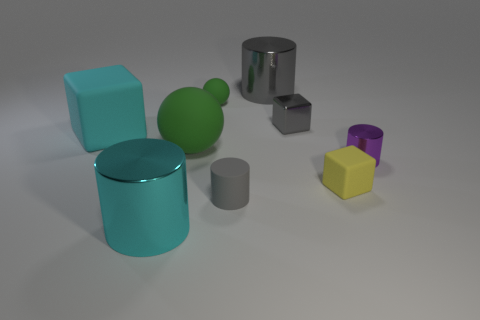There is a object left of the shiny thing that is in front of the tiny purple metallic cylinder; what is its material?
Provide a short and direct response. Rubber. Is the number of tiny things that are behind the cyan matte block greater than the number of tiny yellow things?
Offer a terse response. Yes. Are any tiny blue things visible?
Provide a succinct answer. No. There is a big cylinder that is in front of the large rubber cube; what color is it?
Make the answer very short. Cyan. There is a ball that is the same size as the yellow rubber object; what is its material?
Offer a very short reply. Rubber. What number of other objects are there of the same material as the gray block?
Provide a short and direct response. 3. There is a large thing that is both left of the big green matte ball and behind the rubber cylinder; what is its color?
Your answer should be very brief. Cyan. What number of objects are either large metal cylinders that are in front of the rubber cylinder or tiny gray metal cubes?
Make the answer very short. 2. How many other objects are there of the same color as the tiny rubber ball?
Give a very brief answer. 1. Are there the same number of big cyan cylinders to the left of the yellow thing and small yellow objects?
Your response must be concise. Yes. 